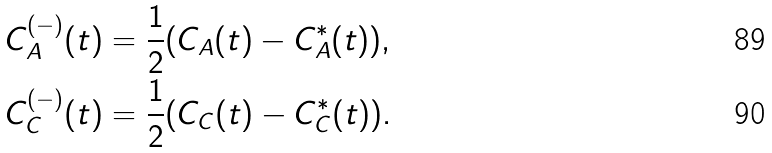<formula> <loc_0><loc_0><loc_500><loc_500>& C _ { A } ^ { ( - ) } ( t ) = \frac { 1 } { 2 } ( C _ { A } ( t ) - C _ { A } ^ { \ast } ( t ) ) , \\ & C _ { C } ^ { ( - ) } ( t ) = \frac { 1 } { 2 } ( C _ { C } ( t ) - C _ { C } ^ { \ast } ( t ) ) .</formula> 